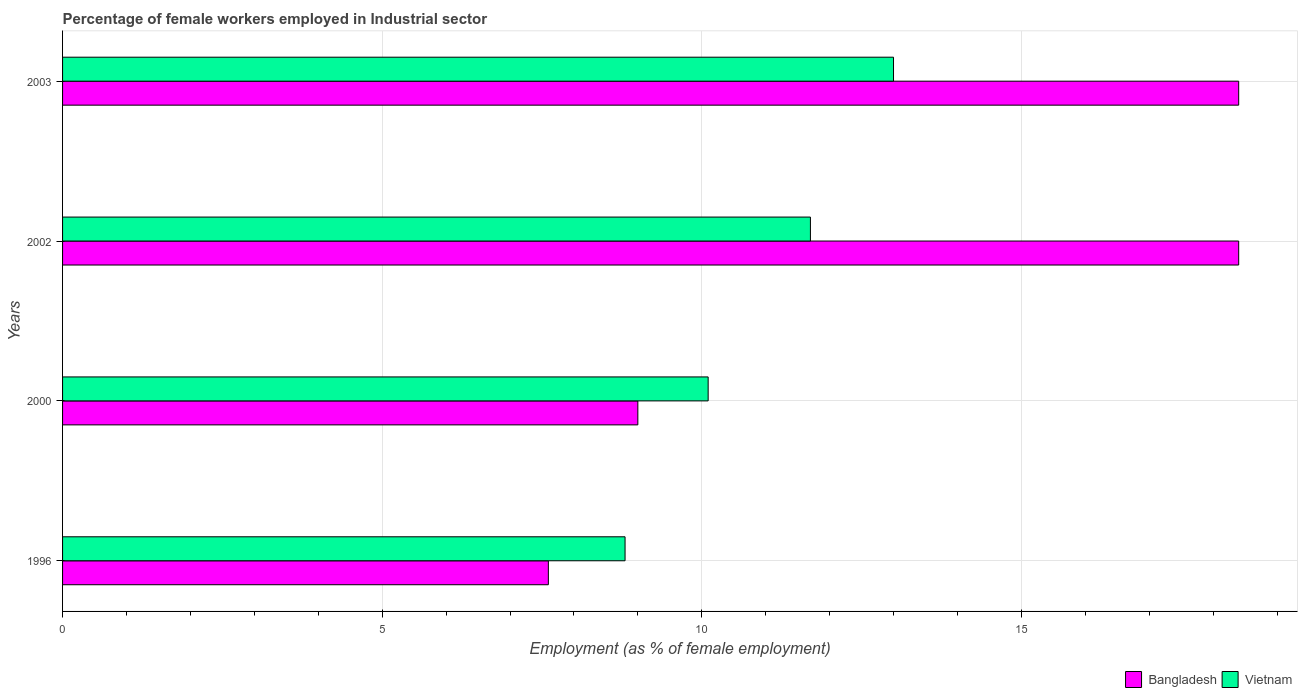How many different coloured bars are there?
Offer a terse response. 2. Are the number of bars per tick equal to the number of legend labels?
Your answer should be compact. Yes. How many bars are there on the 3rd tick from the top?
Your answer should be compact. 2. How many bars are there on the 3rd tick from the bottom?
Provide a short and direct response. 2. What is the label of the 3rd group of bars from the top?
Your answer should be compact. 2000. In how many cases, is the number of bars for a given year not equal to the number of legend labels?
Make the answer very short. 0. What is the percentage of females employed in Industrial sector in Bangladesh in 2002?
Your response must be concise. 18.4. Across all years, what is the maximum percentage of females employed in Industrial sector in Vietnam?
Offer a very short reply. 13. Across all years, what is the minimum percentage of females employed in Industrial sector in Bangladesh?
Give a very brief answer. 7.6. What is the total percentage of females employed in Industrial sector in Vietnam in the graph?
Offer a very short reply. 43.6. What is the difference between the percentage of females employed in Industrial sector in Vietnam in 2000 and that in 2003?
Your answer should be compact. -2.9. What is the difference between the percentage of females employed in Industrial sector in Vietnam in 1996 and the percentage of females employed in Industrial sector in Bangladesh in 2003?
Your response must be concise. -9.6. What is the average percentage of females employed in Industrial sector in Bangladesh per year?
Provide a succinct answer. 13.35. In the year 2002, what is the difference between the percentage of females employed in Industrial sector in Vietnam and percentage of females employed in Industrial sector in Bangladesh?
Offer a very short reply. -6.7. In how many years, is the percentage of females employed in Industrial sector in Bangladesh greater than 7 %?
Make the answer very short. 4. What is the ratio of the percentage of females employed in Industrial sector in Bangladesh in 1996 to that in 2000?
Your response must be concise. 0.84. Is the percentage of females employed in Industrial sector in Bangladesh in 2000 less than that in 2002?
Ensure brevity in your answer.  Yes. Is the difference between the percentage of females employed in Industrial sector in Vietnam in 1996 and 2002 greater than the difference between the percentage of females employed in Industrial sector in Bangladesh in 1996 and 2002?
Ensure brevity in your answer.  Yes. What is the difference between the highest and the second highest percentage of females employed in Industrial sector in Vietnam?
Make the answer very short. 1.3. What is the difference between the highest and the lowest percentage of females employed in Industrial sector in Bangladesh?
Keep it short and to the point. 10.8. In how many years, is the percentage of females employed in Industrial sector in Bangladesh greater than the average percentage of females employed in Industrial sector in Bangladesh taken over all years?
Make the answer very short. 2. Is the sum of the percentage of females employed in Industrial sector in Bangladesh in 1996 and 2002 greater than the maximum percentage of females employed in Industrial sector in Vietnam across all years?
Provide a short and direct response. Yes. What does the 2nd bar from the top in 1996 represents?
Offer a terse response. Bangladesh. Are all the bars in the graph horizontal?
Your answer should be compact. Yes. What is the difference between two consecutive major ticks on the X-axis?
Make the answer very short. 5. Where does the legend appear in the graph?
Make the answer very short. Bottom right. What is the title of the graph?
Make the answer very short. Percentage of female workers employed in Industrial sector. Does "St. Martin (French part)" appear as one of the legend labels in the graph?
Provide a succinct answer. No. What is the label or title of the X-axis?
Offer a very short reply. Employment (as % of female employment). What is the Employment (as % of female employment) of Bangladesh in 1996?
Offer a terse response. 7.6. What is the Employment (as % of female employment) in Vietnam in 1996?
Keep it short and to the point. 8.8. What is the Employment (as % of female employment) of Bangladesh in 2000?
Your response must be concise. 9. What is the Employment (as % of female employment) of Vietnam in 2000?
Ensure brevity in your answer.  10.1. What is the Employment (as % of female employment) in Bangladesh in 2002?
Give a very brief answer. 18.4. What is the Employment (as % of female employment) in Vietnam in 2002?
Your answer should be very brief. 11.7. What is the Employment (as % of female employment) of Bangladesh in 2003?
Your answer should be compact. 18.4. Across all years, what is the maximum Employment (as % of female employment) of Bangladesh?
Give a very brief answer. 18.4. Across all years, what is the maximum Employment (as % of female employment) in Vietnam?
Provide a succinct answer. 13. Across all years, what is the minimum Employment (as % of female employment) of Bangladesh?
Make the answer very short. 7.6. Across all years, what is the minimum Employment (as % of female employment) in Vietnam?
Keep it short and to the point. 8.8. What is the total Employment (as % of female employment) in Bangladesh in the graph?
Your answer should be compact. 53.4. What is the total Employment (as % of female employment) in Vietnam in the graph?
Keep it short and to the point. 43.6. What is the difference between the Employment (as % of female employment) in Bangladesh in 1996 and that in 2000?
Give a very brief answer. -1.4. What is the difference between the Employment (as % of female employment) in Vietnam in 1996 and that in 2000?
Provide a short and direct response. -1.3. What is the difference between the Employment (as % of female employment) in Bangladesh in 2000 and that in 2002?
Offer a terse response. -9.4. What is the difference between the Employment (as % of female employment) of Vietnam in 2000 and that in 2002?
Offer a terse response. -1.6. What is the difference between the Employment (as % of female employment) in Vietnam in 2000 and that in 2003?
Your answer should be compact. -2.9. What is the difference between the Employment (as % of female employment) in Bangladesh in 1996 and the Employment (as % of female employment) in Vietnam in 2000?
Keep it short and to the point. -2.5. What is the difference between the Employment (as % of female employment) in Bangladesh in 1996 and the Employment (as % of female employment) in Vietnam in 2002?
Keep it short and to the point. -4.1. What is the difference between the Employment (as % of female employment) in Bangladesh in 2000 and the Employment (as % of female employment) in Vietnam in 2002?
Make the answer very short. -2.7. What is the difference between the Employment (as % of female employment) of Bangladesh in 2000 and the Employment (as % of female employment) of Vietnam in 2003?
Provide a succinct answer. -4. What is the difference between the Employment (as % of female employment) in Bangladesh in 2002 and the Employment (as % of female employment) in Vietnam in 2003?
Make the answer very short. 5.4. What is the average Employment (as % of female employment) of Bangladesh per year?
Your answer should be compact. 13.35. What is the average Employment (as % of female employment) of Vietnam per year?
Your answer should be very brief. 10.9. In the year 1996, what is the difference between the Employment (as % of female employment) of Bangladesh and Employment (as % of female employment) of Vietnam?
Your answer should be compact. -1.2. In the year 2003, what is the difference between the Employment (as % of female employment) in Bangladesh and Employment (as % of female employment) in Vietnam?
Keep it short and to the point. 5.4. What is the ratio of the Employment (as % of female employment) of Bangladesh in 1996 to that in 2000?
Offer a terse response. 0.84. What is the ratio of the Employment (as % of female employment) of Vietnam in 1996 to that in 2000?
Your answer should be compact. 0.87. What is the ratio of the Employment (as % of female employment) in Bangladesh in 1996 to that in 2002?
Provide a short and direct response. 0.41. What is the ratio of the Employment (as % of female employment) in Vietnam in 1996 to that in 2002?
Ensure brevity in your answer.  0.75. What is the ratio of the Employment (as % of female employment) of Bangladesh in 1996 to that in 2003?
Your response must be concise. 0.41. What is the ratio of the Employment (as % of female employment) of Vietnam in 1996 to that in 2003?
Give a very brief answer. 0.68. What is the ratio of the Employment (as % of female employment) in Bangladesh in 2000 to that in 2002?
Provide a succinct answer. 0.49. What is the ratio of the Employment (as % of female employment) of Vietnam in 2000 to that in 2002?
Provide a short and direct response. 0.86. What is the ratio of the Employment (as % of female employment) of Bangladesh in 2000 to that in 2003?
Your answer should be compact. 0.49. What is the ratio of the Employment (as % of female employment) in Vietnam in 2000 to that in 2003?
Provide a succinct answer. 0.78. What is the ratio of the Employment (as % of female employment) of Bangladesh in 2002 to that in 2003?
Provide a succinct answer. 1. What is the ratio of the Employment (as % of female employment) of Vietnam in 2002 to that in 2003?
Provide a succinct answer. 0.9. What is the difference between the highest and the second highest Employment (as % of female employment) in Bangladesh?
Provide a short and direct response. 0. What is the difference between the highest and the lowest Employment (as % of female employment) in Vietnam?
Offer a terse response. 4.2. 